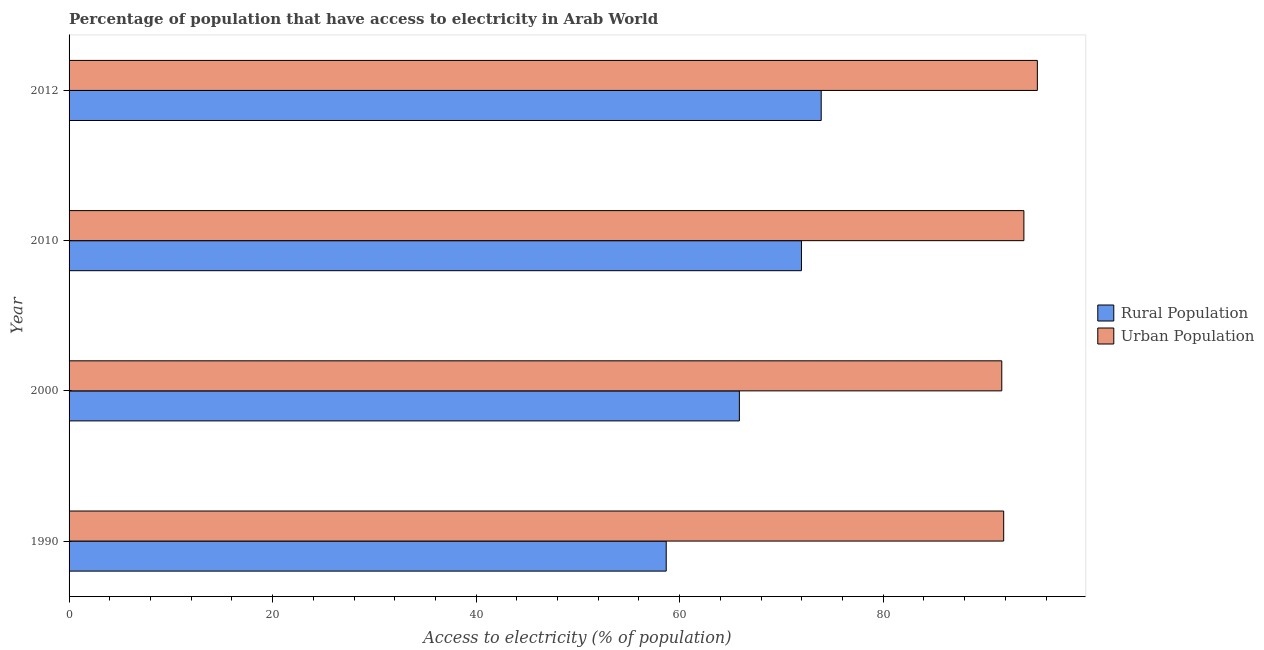How many different coloured bars are there?
Your response must be concise. 2. How many groups of bars are there?
Offer a very short reply. 4. Are the number of bars on each tick of the Y-axis equal?
Make the answer very short. Yes. How many bars are there on the 3rd tick from the top?
Provide a short and direct response. 2. How many bars are there on the 1st tick from the bottom?
Give a very brief answer. 2. What is the label of the 4th group of bars from the top?
Offer a very short reply. 1990. What is the percentage of urban population having access to electricity in 2010?
Offer a very short reply. 93.83. Across all years, what is the maximum percentage of rural population having access to electricity?
Ensure brevity in your answer.  73.91. Across all years, what is the minimum percentage of rural population having access to electricity?
Give a very brief answer. 58.68. In which year was the percentage of urban population having access to electricity maximum?
Provide a succinct answer. 2012. In which year was the percentage of urban population having access to electricity minimum?
Offer a very short reply. 2000. What is the total percentage of rural population having access to electricity in the graph?
Keep it short and to the point. 270.43. What is the difference between the percentage of urban population having access to electricity in 2000 and that in 2010?
Your answer should be compact. -2.17. What is the difference between the percentage of urban population having access to electricity in 2000 and the percentage of rural population having access to electricity in 1990?
Your response must be concise. 32.97. What is the average percentage of urban population having access to electricity per year?
Your answer should be very brief. 93.12. In the year 2000, what is the difference between the percentage of urban population having access to electricity and percentage of rural population having access to electricity?
Provide a short and direct response. 25.79. In how many years, is the percentage of rural population having access to electricity greater than 84 %?
Make the answer very short. 0. What is the ratio of the percentage of rural population having access to electricity in 1990 to that in 2010?
Provide a succinct answer. 0.81. Is the percentage of urban population having access to electricity in 1990 less than that in 2000?
Make the answer very short. No. What is the difference between the highest and the second highest percentage of rural population having access to electricity?
Your response must be concise. 1.94. In how many years, is the percentage of urban population having access to electricity greater than the average percentage of urban population having access to electricity taken over all years?
Give a very brief answer. 2. What does the 1st bar from the top in 2012 represents?
Offer a very short reply. Urban Population. What does the 2nd bar from the bottom in 1990 represents?
Keep it short and to the point. Urban Population. Are all the bars in the graph horizontal?
Your answer should be very brief. Yes. Where does the legend appear in the graph?
Ensure brevity in your answer.  Center right. How many legend labels are there?
Your response must be concise. 2. What is the title of the graph?
Offer a terse response. Percentage of population that have access to electricity in Arab World. What is the label or title of the X-axis?
Give a very brief answer. Access to electricity (% of population). What is the label or title of the Y-axis?
Keep it short and to the point. Year. What is the Access to electricity (% of population) in Rural Population in 1990?
Give a very brief answer. 58.68. What is the Access to electricity (% of population) of Urban Population in 1990?
Keep it short and to the point. 91.84. What is the Access to electricity (% of population) of Rural Population in 2000?
Give a very brief answer. 65.87. What is the Access to electricity (% of population) in Urban Population in 2000?
Provide a short and direct response. 91.65. What is the Access to electricity (% of population) in Rural Population in 2010?
Provide a succinct answer. 71.97. What is the Access to electricity (% of population) in Urban Population in 2010?
Make the answer very short. 93.83. What is the Access to electricity (% of population) of Rural Population in 2012?
Offer a terse response. 73.91. What is the Access to electricity (% of population) of Urban Population in 2012?
Ensure brevity in your answer.  95.15. Across all years, what is the maximum Access to electricity (% of population) of Rural Population?
Your answer should be compact. 73.91. Across all years, what is the maximum Access to electricity (% of population) of Urban Population?
Keep it short and to the point. 95.15. Across all years, what is the minimum Access to electricity (% of population) of Rural Population?
Keep it short and to the point. 58.68. Across all years, what is the minimum Access to electricity (% of population) in Urban Population?
Ensure brevity in your answer.  91.65. What is the total Access to electricity (% of population) of Rural Population in the graph?
Make the answer very short. 270.43. What is the total Access to electricity (% of population) in Urban Population in the graph?
Your answer should be very brief. 372.48. What is the difference between the Access to electricity (% of population) in Rural Population in 1990 and that in 2000?
Keep it short and to the point. -7.19. What is the difference between the Access to electricity (% of population) of Urban Population in 1990 and that in 2000?
Provide a succinct answer. 0.19. What is the difference between the Access to electricity (% of population) of Rural Population in 1990 and that in 2010?
Keep it short and to the point. -13.29. What is the difference between the Access to electricity (% of population) in Urban Population in 1990 and that in 2010?
Make the answer very short. -1.99. What is the difference between the Access to electricity (% of population) of Rural Population in 1990 and that in 2012?
Offer a terse response. -15.23. What is the difference between the Access to electricity (% of population) of Urban Population in 1990 and that in 2012?
Provide a short and direct response. -3.31. What is the difference between the Access to electricity (% of population) in Rural Population in 2000 and that in 2010?
Give a very brief answer. -6.1. What is the difference between the Access to electricity (% of population) in Urban Population in 2000 and that in 2010?
Your answer should be very brief. -2.17. What is the difference between the Access to electricity (% of population) of Rural Population in 2000 and that in 2012?
Ensure brevity in your answer.  -8.04. What is the difference between the Access to electricity (% of population) in Urban Population in 2000 and that in 2012?
Your answer should be very brief. -3.5. What is the difference between the Access to electricity (% of population) in Rural Population in 2010 and that in 2012?
Offer a very short reply. -1.94. What is the difference between the Access to electricity (% of population) in Urban Population in 2010 and that in 2012?
Ensure brevity in your answer.  -1.32. What is the difference between the Access to electricity (% of population) in Rural Population in 1990 and the Access to electricity (% of population) in Urban Population in 2000?
Ensure brevity in your answer.  -32.97. What is the difference between the Access to electricity (% of population) of Rural Population in 1990 and the Access to electricity (% of population) of Urban Population in 2010?
Offer a very short reply. -35.15. What is the difference between the Access to electricity (% of population) of Rural Population in 1990 and the Access to electricity (% of population) of Urban Population in 2012?
Your answer should be compact. -36.47. What is the difference between the Access to electricity (% of population) in Rural Population in 2000 and the Access to electricity (% of population) in Urban Population in 2010?
Provide a succinct answer. -27.96. What is the difference between the Access to electricity (% of population) in Rural Population in 2000 and the Access to electricity (% of population) in Urban Population in 2012?
Give a very brief answer. -29.28. What is the difference between the Access to electricity (% of population) of Rural Population in 2010 and the Access to electricity (% of population) of Urban Population in 2012?
Your answer should be compact. -23.18. What is the average Access to electricity (% of population) of Rural Population per year?
Keep it short and to the point. 67.61. What is the average Access to electricity (% of population) in Urban Population per year?
Make the answer very short. 93.12. In the year 1990, what is the difference between the Access to electricity (% of population) of Rural Population and Access to electricity (% of population) of Urban Population?
Your answer should be compact. -33.16. In the year 2000, what is the difference between the Access to electricity (% of population) in Rural Population and Access to electricity (% of population) in Urban Population?
Ensure brevity in your answer.  -25.79. In the year 2010, what is the difference between the Access to electricity (% of population) in Rural Population and Access to electricity (% of population) in Urban Population?
Your answer should be compact. -21.86. In the year 2012, what is the difference between the Access to electricity (% of population) of Rural Population and Access to electricity (% of population) of Urban Population?
Offer a terse response. -21.24. What is the ratio of the Access to electricity (% of population) in Rural Population in 1990 to that in 2000?
Provide a succinct answer. 0.89. What is the ratio of the Access to electricity (% of population) in Rural Population in 1990 to that in 2010?
Ensure brevity in your answer.  0.82. What is the ratio of the Access to electricity (% of population) in Urban Population in 1990 to that in 2010?
Provide a succinct answer. 0.98. What is the ratio of the Access to electricity (% of population) of Rural Population in 1990 to that in 2012?
Offer a very short reply. 0.79. What is the ratio of the Access to electricity (% of population) of Urban Population in 1990 to that in 2012?
Keep it short and to the point. 0.97. What is the ratio of the Access to electricity (% of population) of Rural Population in 2000 to that in 2010?
Your response must be concise. 0.92. What is the ratio of the Access to electricity (% of population) of Urban Population in 2000 to that in 2010?
Ensure brevity in your answer.  0.98. What is the ratio of the Access to electricity (% of population) in Rural Population in 2000 to that in 2012?
Offer a terse response. 0.89. What is the ratio of the Access to electricity (% of population) in Urban Population in 2000 to that in 2012?
Keep it short and to the point. 0.96. What is the ratio of the Access to electricity (% of population) of Rural Population in 2010 to that in 2012?
Your answer should be very brief. 0.97. What is the ratio of the Access to electricity (% of population) in Urban Population in 2010 to that in 2012?
Make the answer very short. 0.99. What is the difference between the highest and the second highest Access to electricity (% of population) in Rural Population?
Give a very brief answer. 1.94. What is the difference between the highest and the second highest Access to electricity (% of population) of Urban Population?
Your answer should be very brief. 1.32. What is the difference between the highest and the lowest Access to electricity (% of population) of Rural Population?
Offer a terse response. 15.23. What is the difference between the highest and the lowest Access to electricity (% of population) of Urban Population?
Make the answer very short. 3.5. 